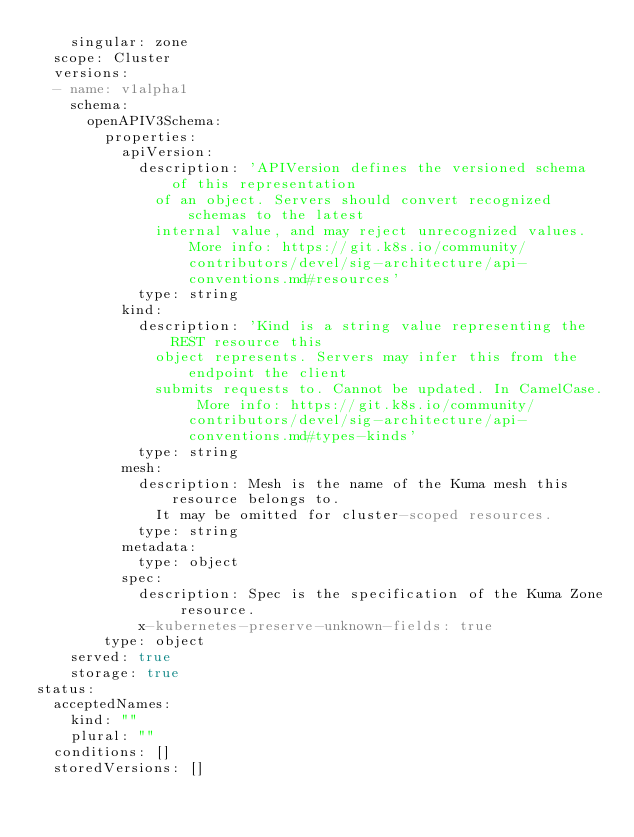Convert code to text. <code><loc_0><loc_0><loc_500><loc_500><_YAML_>    singular: zone
  scope: Cluster
  versions:
  - name: v1alpha1
    schema:
      openAPIV3Schema:
        properties:
          apiVersion:
            description: 'APIVersion defines the versioned schema of this representation
              of an object. Servers should convert recognized schemas to the latest
              internal value, and may reject unrecognized values. More info: https://git.k8s.io/community/contributors/devel/sig-architecture/api-conventions.md#resources'
            type: string
          kind:
            description: 'Kind is a string value representing the REST resource this
              object represents. Servers may infer this from the endpoint the client
              submits requests to. Cannot be updated. In CamelCase. More info: https://git.k8s.io/community/contributors/devel/sig-architecture/api-conventions.md#types-kinds'
            type: string
          mesh:
            description: Mesh is the name of the Kuma mesh this resource belongs to.
              It may be omitted for cluster-scoped resources.
            type: string
          metadata:
            type: object
          spec:
            description: Spec is the specification of the Kuma Zone resource.
            x-kubernetes-preserve-unknown-fields: true
        type: object
    served: true
    storage: true
status:
  acceptedNames:
    kind: ""
    plural: ""
  conditions: []
  storedVersions: []
</code> 